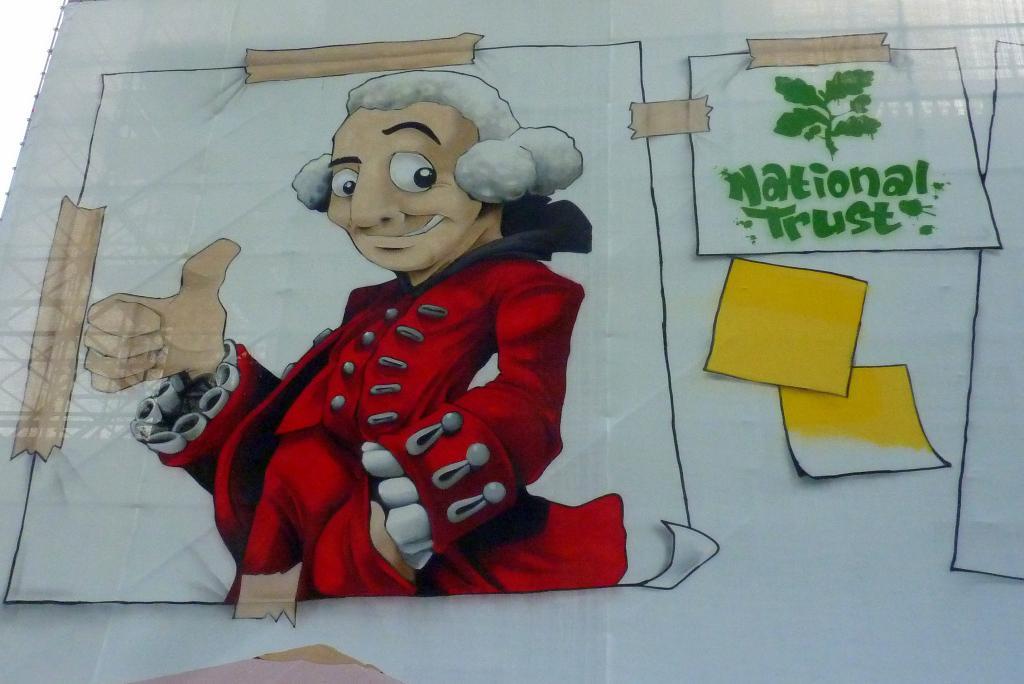What is written in green?
Offer a very short reply. National trust. 